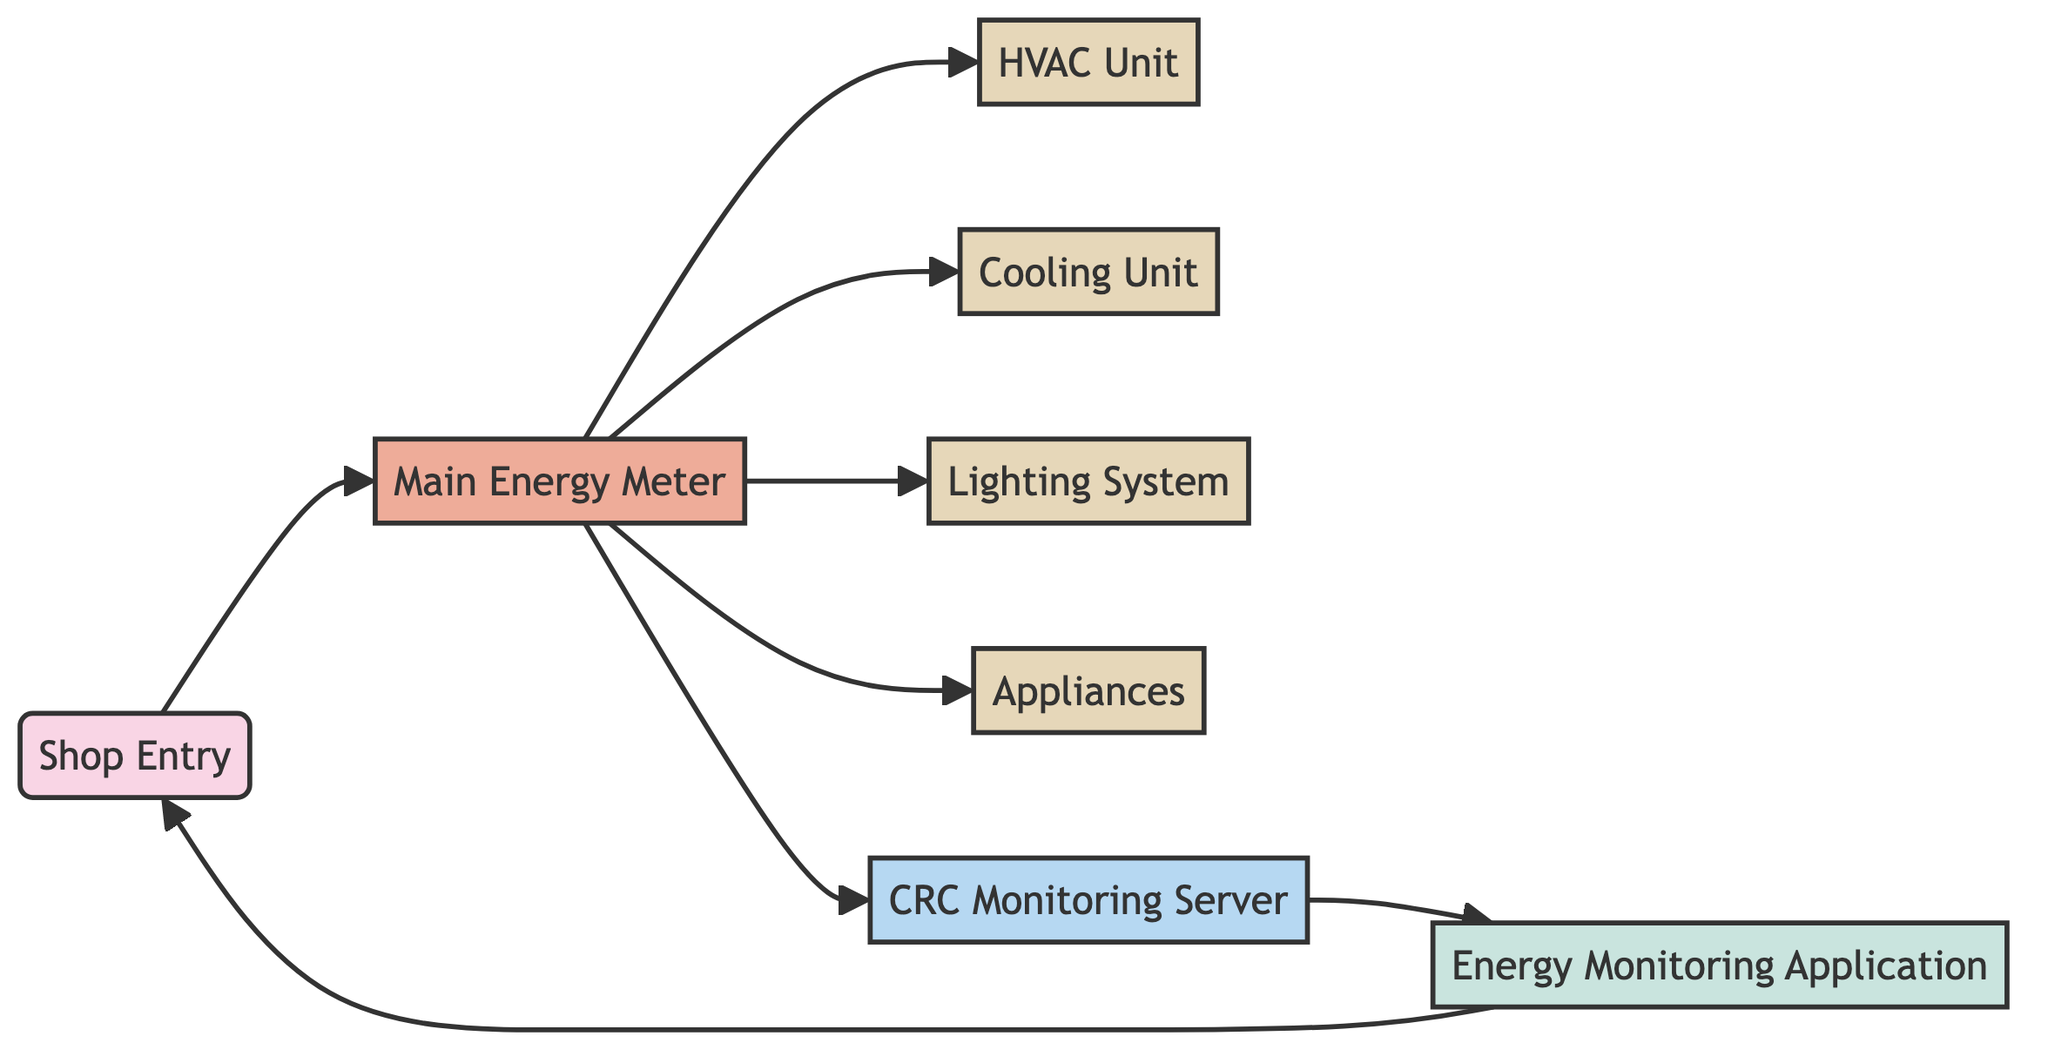What type is the main energy meter? The main energy meter is labeled as "Main Energy Meter" and categorized under the type "meter" in the diagram.
Answer: meter How many devices are connected to the main meter? The main meter is connected to four devices: HVAC Unit, Cooling Unit, Lighting System, and Appliances. Counting these gives a total of four devices.
Answer: 4 What is the endpoint in this network diagram? The diagram indicates "Shop Entry" as the only endpoint, which represents the starting point for energy flow.
Answer: Shop Entry Which component connects directly to the energy monitoring application? According to the diagram, the CRC Monitoring Server is the component that connects directly to the Energy Monitoring Application.
Answer: CRC Monitoring Server What direction does energy flow from the shop entry? The energy flow starts at the Shop Entry and then moves to the Main Energy Meter, indicating the direction can be described as Shop Entry to Main Energy Meter.
Answer: Main Energy Meter How many total edges are in this network diagram? The diagram shows a total of seven edges that connect various nodes, indicating how they interact within the energy monitoring system.
Answer: 7 What is the role of the CRC Monitoring Server? The CRC Monitoring Server acts as a mediator between the Main Energy Meter and the Energy Monitoring Application, enabling monitoring and management of energy data.
Answer: Mediator Which devices are monitored through the main meter? The devices monitored through the Main Energy Meter include HVAC Unit, Cooling Unit, Lighting System, and Appliances, which are linked to it directly.
Answer: HVAC Unit, Cooling Unit, Lighting System, Appliances What is the last step in the energy monitoring flow? The last step in the energy monitoring flow is the connection from the Energy Monitoring Application back to the Shop Entry, indicating a feedback loop.
Answer: Shop Entry 